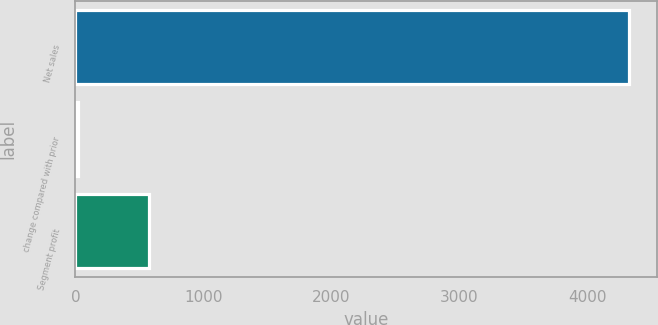Convert chart to OTSL. <chart><loc_0><loc_0><loc_500><loc_500><bar_chart><fcel>Net sales<fcel>change compared with prior<fcel>Segment profit<nl><fcel>4323<fcel>18<fcel>575<nl></chart> 